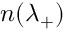Convert formula to latex. <formula><loc_0><loc_0><loc_500><loc_500>n ( \lambda _ { + } )</formula> 